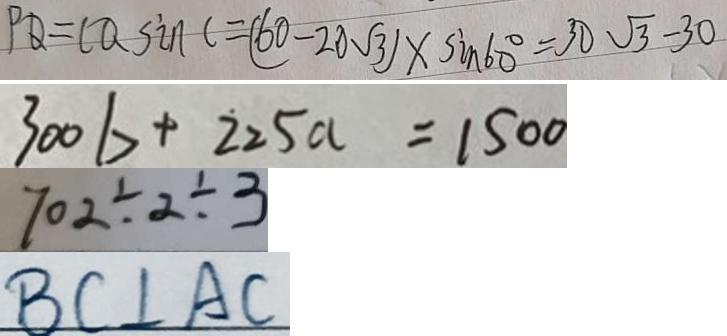<formula> <loc_0><loc_0><loc_500><loc_500>P Q = C Q \sin C = ( 6 0 - 2 0 \sqrt { 3 } ) \times \sin 6 0 ^ { \circ } = 3 0 \sqrt { 3 } - 3 0 
 3 0 0 b + 2 2 5 a = 1 5 0 0 
 7 0 2 \div 2 \div 3 
 B C \bot A C</formula> 